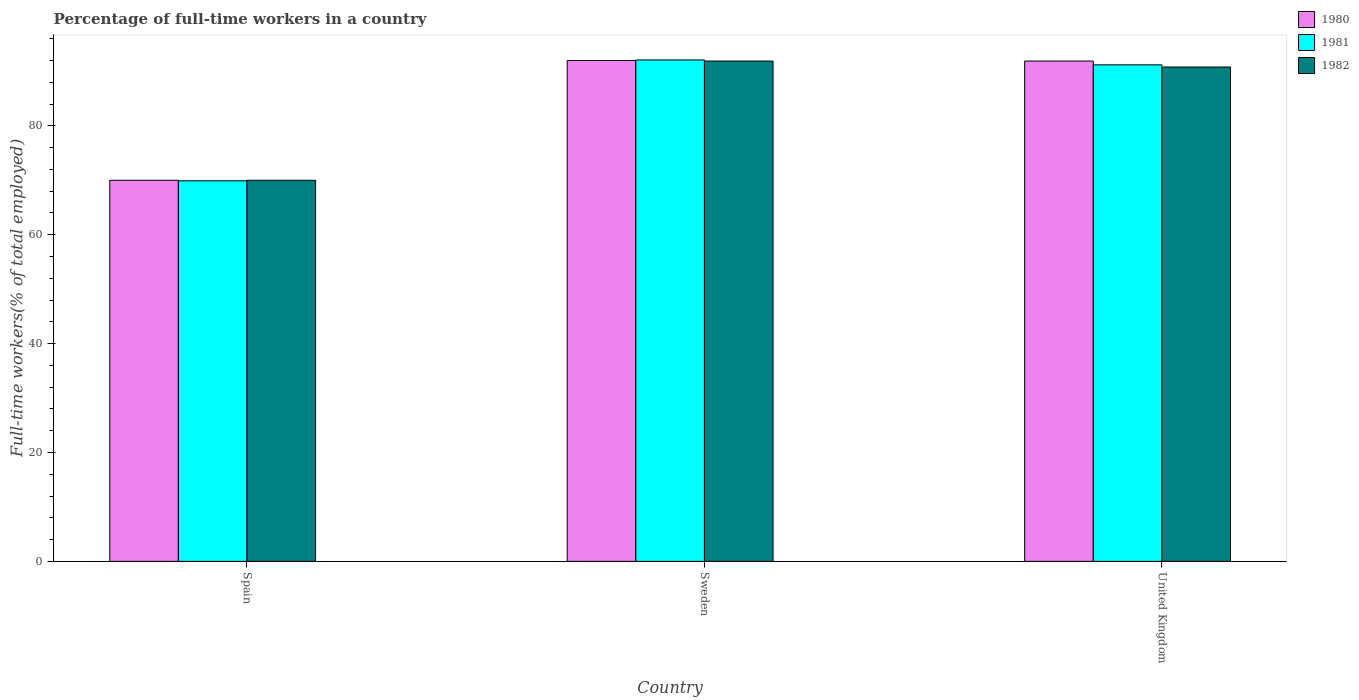How many groups of bars are there?
Offer a terse response. 3. Are the number of bars on each tick of the X-axis equal?
Offer a terse response. Yes. What is the percentage of full-time workers in 1982 in United Kingdom?
Provide a short and direct response. 90.8. Across all countries, what is the maximum percentage of full-time workers in 1982?
Offer a terse response. 91.9. In which country was the percentage of full-time workers in 1982 maximum?
Your response must be concise. Sweden. What is the total percentage of full-time workers in 1981 in the graph?
Keep it short and to the point. 253.2. What is the difference between the percentage of full-time workers in 1981 in Spain and that in Sweden?
Give a very brief answer. -22.2. What is the difference between the percentage of full-time workers in 1981 in Spain and the percentage of full-time workers in 1980 in Sweden?
Give a very brief answer. -22.1. What is the average percentage of full-time workers in 1981 per country?
Provide a short and direct response. 84.4. What is the difference between the percentage of full-time workers of/in 1982 and percentage of full-time workers of/in 1980 in Spain?
Ensure brevity in your answer.  0. What is the ratio of the percentage of full-time workers in 1981 in Sweden to that in United Kingdom?
Keep it short and to the point. 1.01. Is the percentage of full-time workers in 1982 in Spain less than that in Sweden?
Keep it short and to the point. Yes. Is the difference between the percentage of full-time workers in 1982 in Spain and United Kingdom greater than the difference between the percentage of full-time workers in 1980 in Spain and United Kingdom?
Your answer should be compact. Yes. What is the difference between the highest and the second highest percentage of full-time workers in 1981?
Keep it short and to the point. -0.9. What is the difference between the highest and the lowest percentage of full-time workers in 1982?
Give a very brief answer. 21.9. In how many countries, is the percentage of full-time workers in 1982 greater than the average percentage of full-time workers in 1982 taken over all countries?
Your response must be concise. 2. What does the 1st bar from the right in United Kingdom represents?
Give a very brief answer. 1982. Is it the case that in every country, the sum of the percentage of full-time workers in 1980 and percentage of full-time workers in 1981 is greater than the percentage of full-time workers in 1982?
Offer a terse response. Yes. How many bars are there?
Offer a very short reply. 9. Are the values on the major ticks of Y-axis written in scientific E-notation?
Keep it short and to the point. No. Where does the legend appear in the graph?
Your response must be concise. Top right. How many legend labels are there?
Offer a terse response. 3. What is the title of the graph?
Your answer should be compact. Percentage of full-time workers in a country. Does "1978" appear as one of the legend labels in the graph?
Provide a succinct answer. No. What is the label or title of the X-axis?
Make the answer very short. Country. What is the label or title of the Y-axis?
Make the answer very short. Full-time workers(% of total employed). What is the Full-time workers(% of total employed) in 1981 in Spain?
Make the answer very short. 69.9. What is the Full-time workers(% of total employed) of 1980 in Sweden?
Offer a terse response. 92. What is the Full-time workers(% of total employed) in 1981 in Sweden?
Offer a very short reply. 92.1. What is the Full-time workers(% of total employed) of 1982 in Sweden?
Your answer should be very brief. 91.9. What is the Full-time workers(% of total employed) of 1980 in United Kingdom?
Your answer should be compact. 91.9. What is the Full-time workers(% of total employed) in 1981 in United Kingdom?
Give a very brief answer. 91.2. What is the Full-time workers(% of total employed) in 1982 in United Kingdom?
Your answer should be compact. 90.8. Across all countries, what is the maximum Full-time workers(% of total employed) of 1980?
Keep it short and to the point. 92. Across all countries, what is the maximum Full-time workers(% of total employed) of 1981?
Provide a short and direct response. 92.1. Across all countries, what is the maximum Full-time workers(% of total employed) in 1982?
Give a very brief answer. 91.9. Across all countries, what is the minimum Full-time workers(% of total employed) in 1980?
Your response must be concise. 70. Across all countries, what is the minimum Full-time workers(% of total employed) in 1981?
Provide a succinct answer. 69.9. Across all countries, what is the minimum Full-time workers(% of total employed) of 1982?
Provide a succinct answer. 70. What is the total Full-time workers(% of total employed) of 1980 in the graph?
Ensure brevity in your answer.  253.9. What is the total Full-time workers(% of total employed) of 1981 in the graph?
Give a very brief answer. 253.2. What is the total Full-time workers(% of total employed) in 1982 in the graph?
Offer a terse response. 252.7. What is the difference between the Full-time workers(% of total employed) in 1980 in Spain and that in Sweden?
Make the answer very short. -22. What is the difference between the Full-time workers(% of total employed) in 1981 in Spain and that in Sweden?
Provide a short and direct response. -22.2. What is the difference between the Full-time workers(% of total employed) in 1982 in Spain and that in Sweden?
Keep it short and to the point. -21.9. What is the difference between the Full-time workers(% of total employed) in 1980 in Spain and that in United Kingdom?
Offer a very short reply. -21.9. What is the difference between the Full-time workers(% of total employed) in 1981 in Spain and that in United Kingdom?
Make the answer very short. -21.3. What is the difference between the Full-time workers(% of total employed) of 1982 in Spain and that in United Kingdom?
Provide a succinct answer. -20.8. What is the difference between the Full-time workers(% of total employed) in 1980 in Sweden and that in United Kingdom?
Keep it short and to the point. 0.1. What is the difference between the Full-time workers(% of total employed) of 1981 in Sweden and that in United Kingdom?
Make the answer very short. 0.9. What is the difference between the Full-time workers(% of total employed) in 1980 in Spain and the Full-time workers(% of total employed) in 1981 in Sweden?
Offer a terse response. -22.1. What is the difference between the Full-time workers(% of total employed) in 1980 in Spain and the Full-time workers(% of total employed) in 1982 in Sweden?
Ensure brevity in your answer.  -21.9. What is the difference between the Full-time workers(% of total employed) in 1981 in Spain and the Full-time workers(% of total employed) in 1982 in Sweden?
Keep it short and to the point. -22. What is the difference between the Full-time workers(% of total employed) in 1980 in Spain and the Full-time workers(% of total employed) in 1981 in United Kingdom?
Keep it short and to the point. -21.2. What is the difference between the Full-time workers(% of total employed) in 1980 in Spain and the Full-time workers(% of total employed) in 1982 in United Kingdom?
Make the answer very short. -20.8. What is the difference between the Full-time workers(% of total employed) in 1981 in Spain and the Full-time workers(% of total employed) in 1982 in United Kingdom?
Ensure brevity in your answer.  -20.9. What is the difference between the Full-time workers(% of total employed) in 1980 in Sweden and the Full-time workers(% of total employed) in 1981 in United Kingdom?
Make the answer very short. 0.8. What is the average Full-time workers(% of total employed) of 1980 per country?
Make the answer very short. 84.63. What is the average Full-time workers(% of total employed) of 1981 per country?
Provide a succinct answer. 84.4. What is the average Full-time workers(% of total employed) in 1982 per country?
Offer a terse response. 84.23. What is the difference between the Full-time workers(% of total employed) of 1980 and Full-time workers(% of total employed) of 1981 in Sweden?
Keep it short and to the point. -0.1. What is the difference between the Full-time workers(% of total employed) in 1980 and Full-time workers(% of total employed) in 1982 in Sweden?
Offer a very short reply. 0.1. What is the difference between the Full-time workers(% of total employed) in 1980 and Full-time workers(% of total employed) in 1981 in United Kingdom?
Your answer should be very brief. 0.7. What is the ratio of the Full-time workers(% of total employed) in 1980 in Spain to that in Sweden?
Offer a terse response. 0.76. What is the ratio of the Full-time workers(% of total employed) of 1981 in Spain to that in Sweden?
Make the answer very short. 0.76. What is the ratio of the Full-time workers(% of total employed) of 1982 in Spain to that in Sweden?
Your answer should be compact. 0.76. What is the ratio of the Full-time workers(% of total employed) of 1980 in Spain to that in United Kingdom?
Your response must be concise. 0.76. What is the ratio of the Full-time workers(% of total employed) of 1981 in Spain to that in United Kingdom?
Offer a terse response. 0.77. What is the ratio of the Full-time workers(% of total employed) of 1982 in Spain to that in United Kingdom?
Provide a succinct answer. 0.77. What is the ratio of the Full-time workers(% of total employed) of 1980 in Sweden to that in United Kingdom?
Your answer should be compact. 1. What is the ratio of the Full-time workers(% of total employed) in 1981 in Sweden to that in United Kingdom?
Give a very brief answer. 1.01. What is the ratio of the Full-time workers(% of total employed) in 1982 in Sweden to that in United Kingdom?
Keep it short and to the point. 1.01. What is the difference between the highest and the second highest Full-time workers(% of total employed) of 1980?
Provide a succinct answer. 0.1. What is the difference between the highest and the second highest Full-time workers(% of total employed) of 1981?
Your answer should be compact. 0.9. What is the difference between the highest and the lowest Full-time workers(% of total employed) of 1980?
Keep it short and to the point. 22. What is the difference between the highest and the lowest Full-time workers(% of total employed) of 1981?
Your answer should be very brief. 22.2. What is the difference between the highest and the lowest Full-time workers(% of total employed) of 1982?
Make the answer very short. 21.9. 